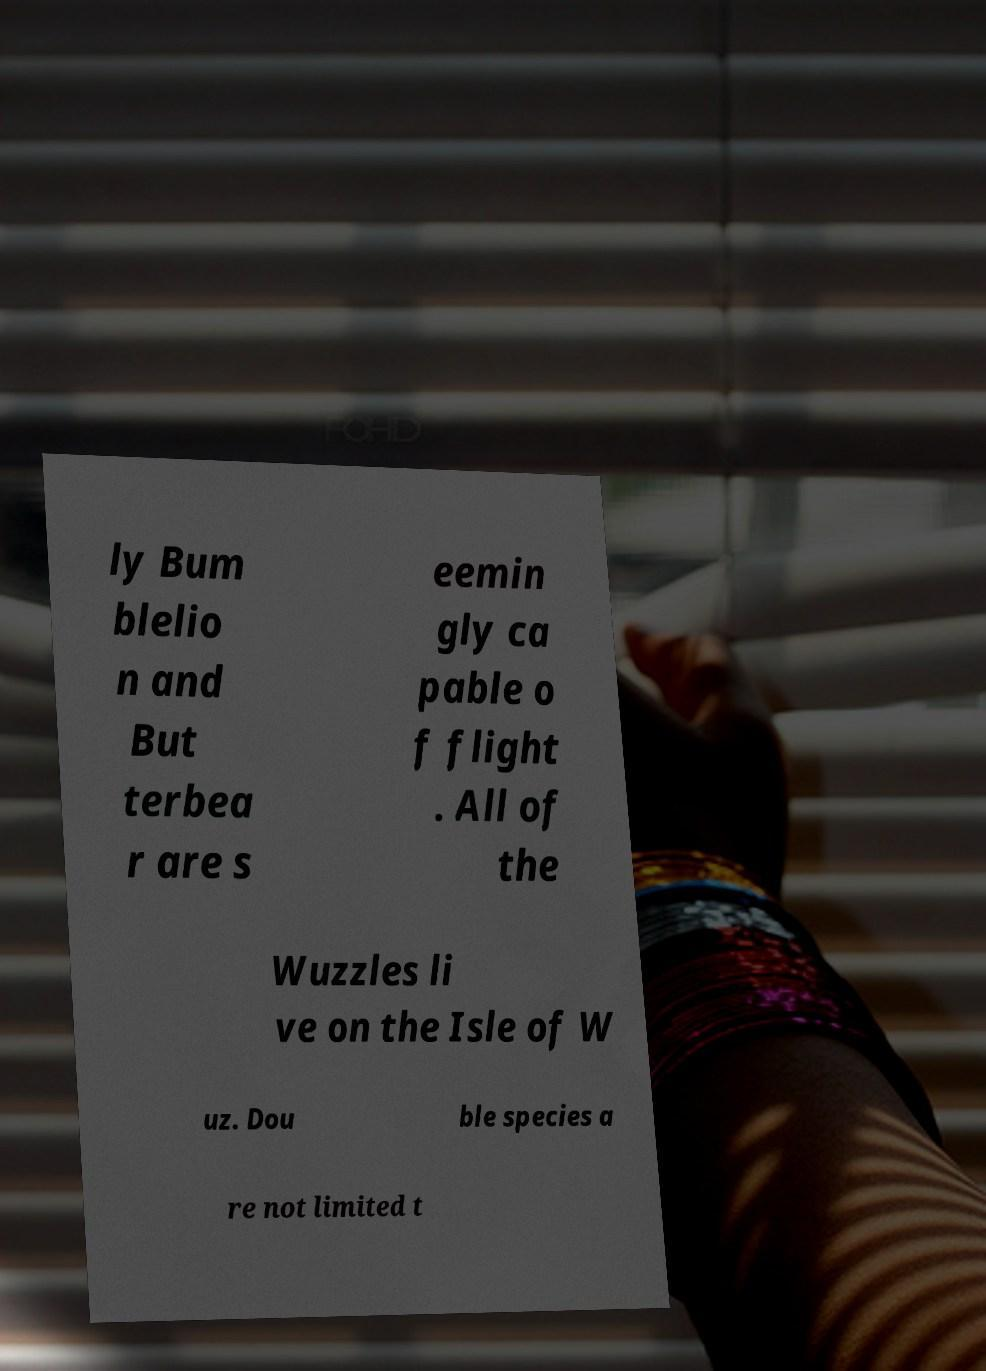For documentation purposes, I need the text within this image transcribed. Could you provide that? ly Bum blelio n and But terbea r are s eemin gly ca pable o f flight . All of the Wuzzles li ve on the Isle of W uz. Dou ble species a re not limited t 